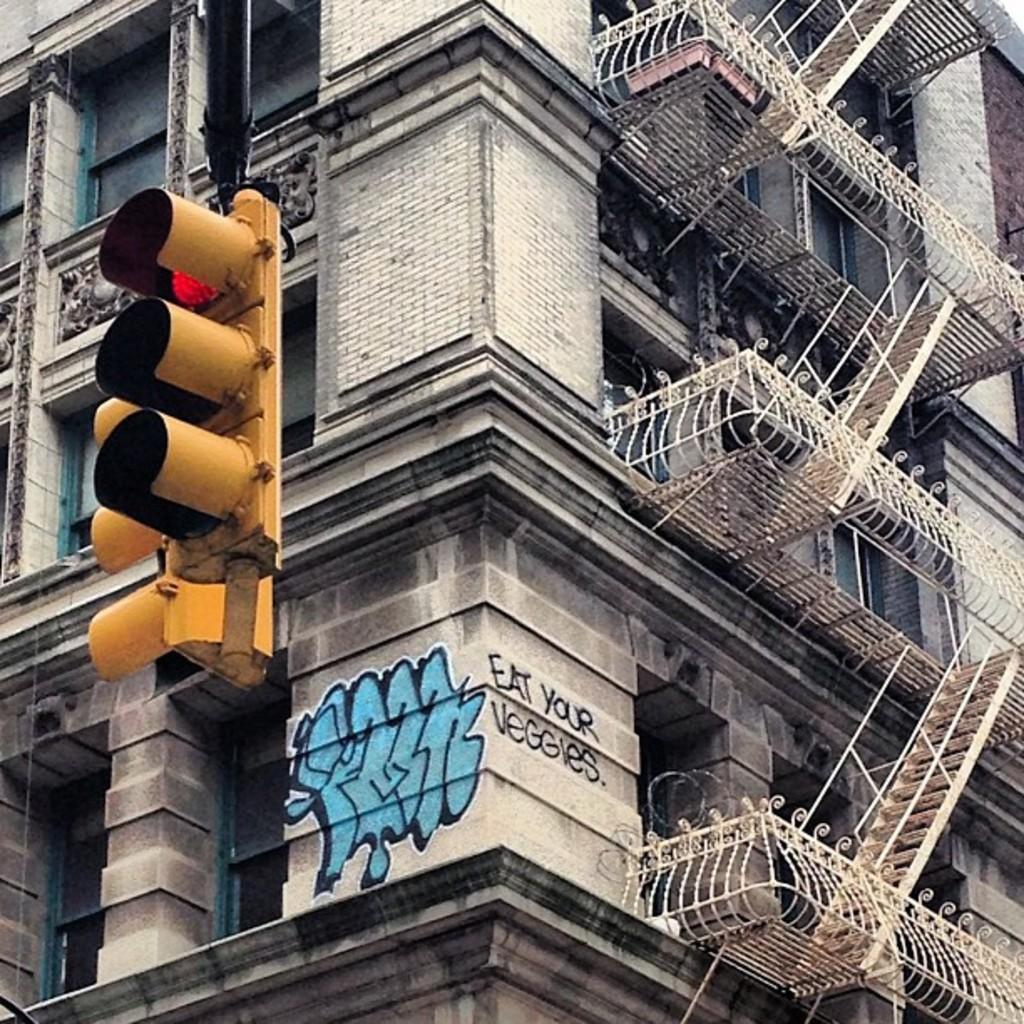How would you summarize this image in a sentence or two? In this image we can see a building with pillars, staircase, some text and a picture on a wall. We can also see some traffic lights. 